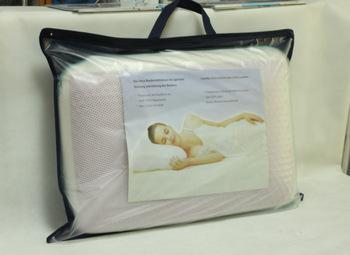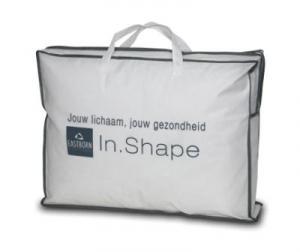The first image is the image on the left, the second image is the image on the right. Examine the images to the left and right. Is the description "There are 2 white pillows in bags with handles." accurate? Answer yes or no. Yes. The first image is the image on the left, the second image is the image on the right. Considering the images on both sides, is "Each image shows a bag that holds a pillow, at least one bag is transparent, and the bag on the right has double handles." valid? Answer yes or no. Yes. 